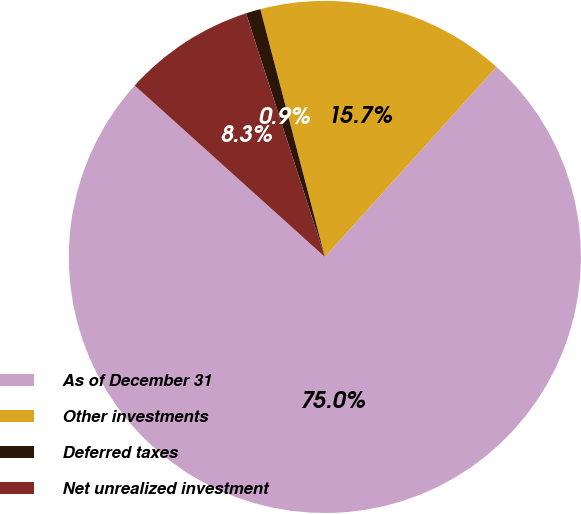Convert chart to OTSL. <chart><loc_0><loc_0><loc_500><loc_500><pie_chart><fcel>As of December 31<fcel>Other investments<fcel>Deferred taxes<fcel>Net unrealized investment<nl><fcel>74.99%<fcel>15.74%<fcel>0.93%<fcel>8.34%<nl></chart> 